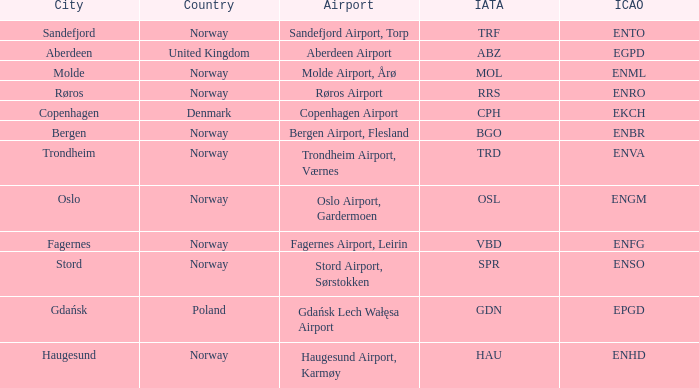What is City of Sandefjord in Norway's IATA? TRF. 